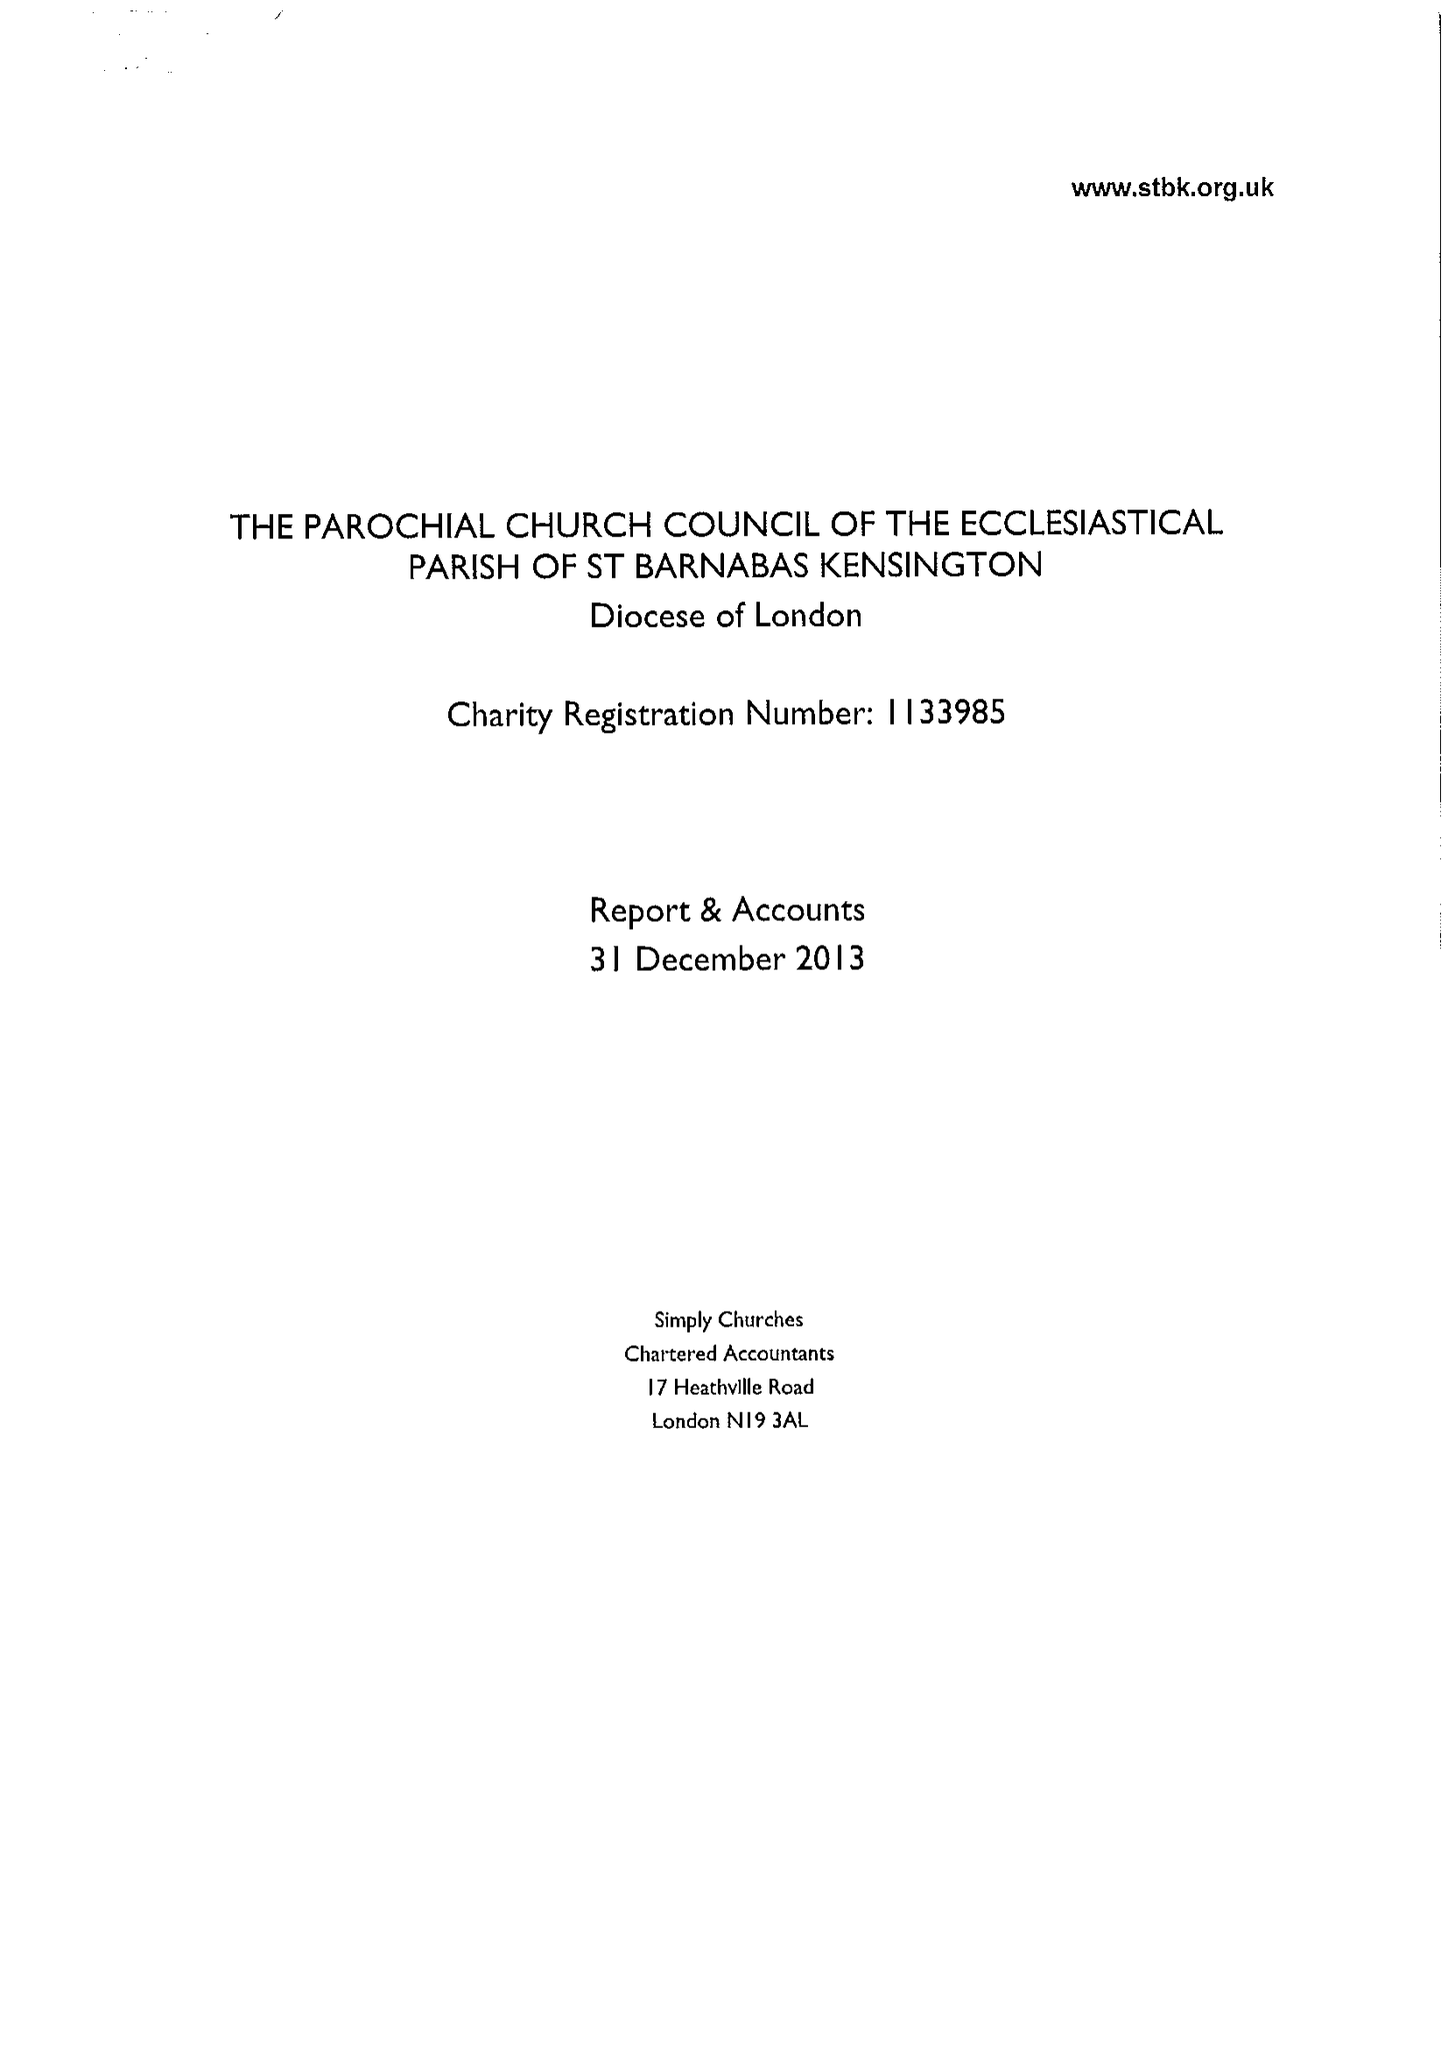What is the value for the charity_number?
Answer the question using a single word or phrase. 1133985 